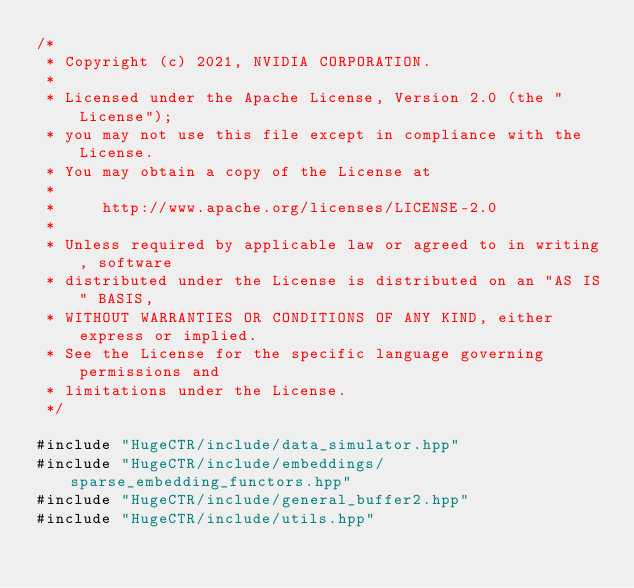Convert code to text. <code><loc_0><loc_0><loc_500><loc_500><_Cuda_>/*
 * Copyright (c) 2021, NVIDIA CORPORATION.
 *
 * Licensed under the Apache License, Version 2.0 (the "License");
 * you may not use this file except in compliance with the License.
 * You may obtain a copy of the License at
 *
 *     http://www.apache.org/licenses/LICENSE-2.0
 *
 * Unless required by applicable law or agreed to in writing, software
 * distributed under the License is distributed on an "AS IS" BASIS,
 * WITHOUT WARRANTIES OR CONDITIONS OF ANY KIND, either express or implied.
 * See the License for the specific language governing permissions and
 * limitations under the License.
 */

#include "HugeCTR/include/data_simulator.hpp"
#include "HugeCTR/include/embeddings/sparse_embedding_functors.hpp"
#include "HugeCTR/include/general_buffer2.hpp"
#include "HugeCTR/include/utils.hpp"
</code> 